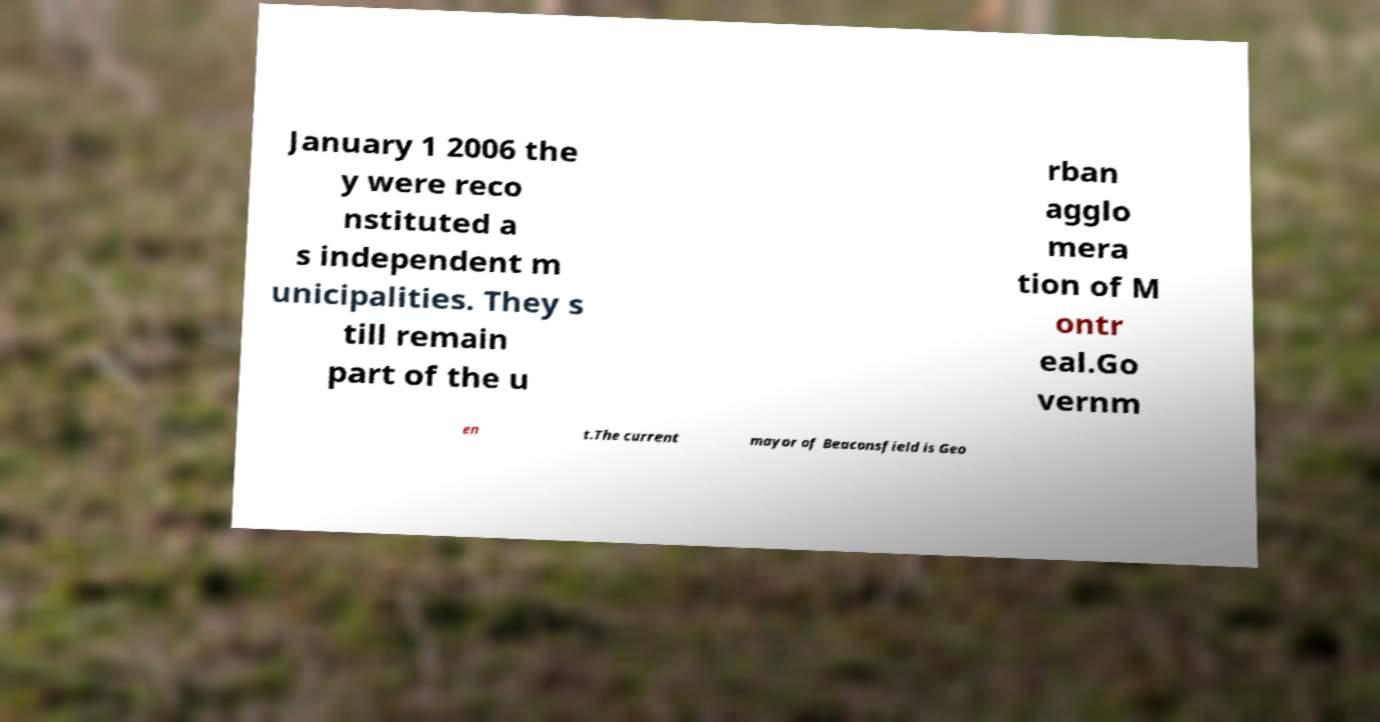For documentation purposes, I need the text within this image transcribed. Could you provide that? January 1 2006 the y were reco nstituted a s independent m unicipalities. They s till remain part of the u rban agglo mera tion of M ontr eal.Go vernm en t.The current mayor of Beaconsfield is Geo 